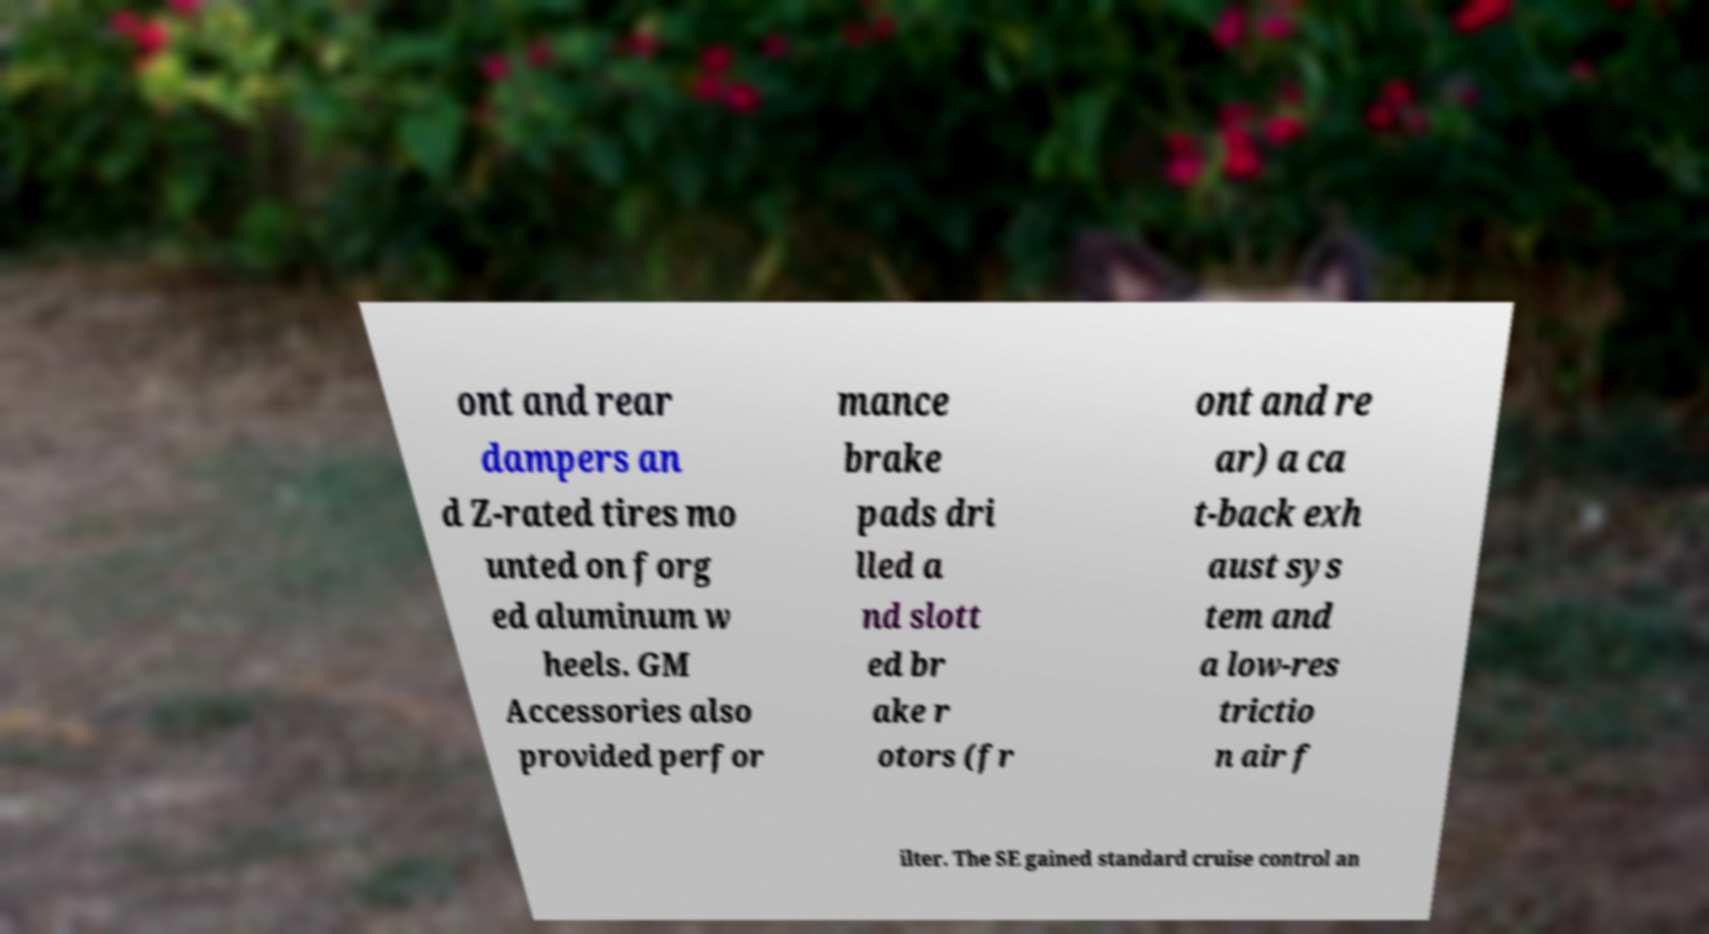I need the written content from this picture converted into text. Can you do that? ont and rear dampers an d Z-rated tires mo unted on forg ed aluminum w heels. GM Accessories also provided perfor mance brake pads dri lled a nd slott ed br ake r otors (fr ont and re ar) a ca t-back exh aust sys tem and a low-res trictio n air f ilter. The SE gained standard cruise control an 